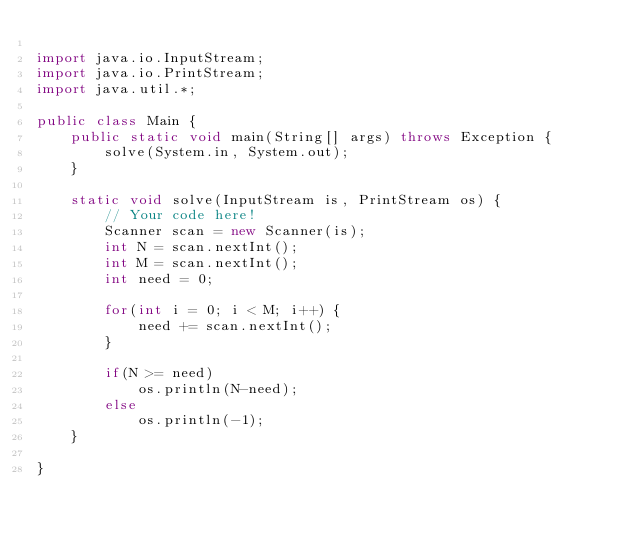<code> <loc_0><loc_0><loc_500><loc_500><_Java_>
import java.io.InputStream;
import java.io.PrintStream;
import java.util.*;

public class Main {
    public static void main(String[] args) throws Exception {
        solve(System.in, System.out);
    }

    static void solve(InputStream is, PrintStream os) {
        // Your code here!
        Scanner scan = new Scanner(is);
        int N = scan.nextInt();
        int M = scan.nextInt();
        int need = 0;

        for(int i = 0; i < M; i++) {
            need += scan.nextInt();
        }

        if(N >= need)
            os.println(N-need);
        else
            os.println(-1);
    }

}</code> 